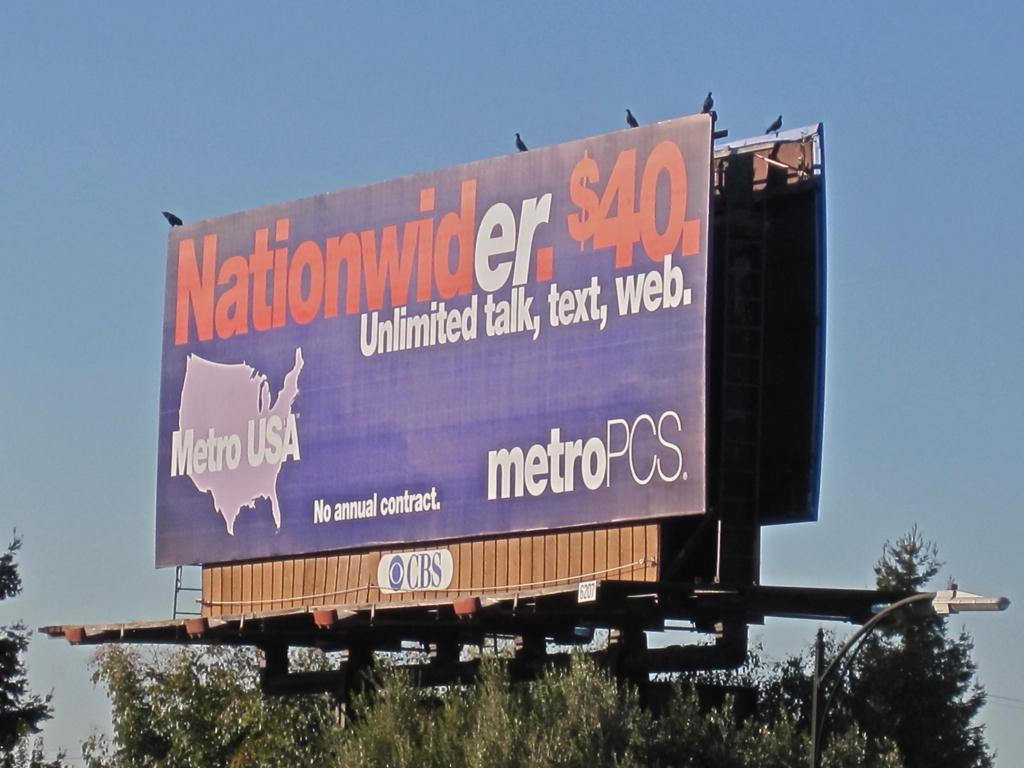<image>
Write a terse but informative summary of the picture. a billboard that says 'nationwider. $40. unlimited talk, text, web.' 